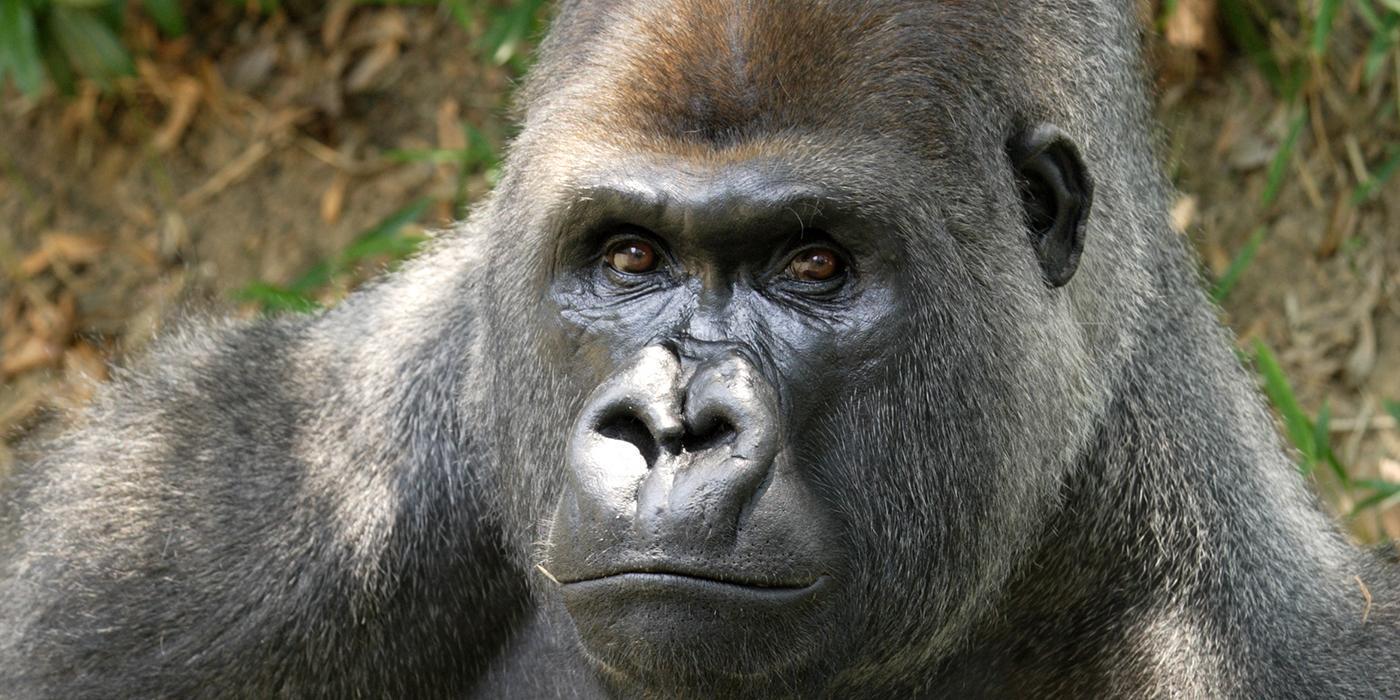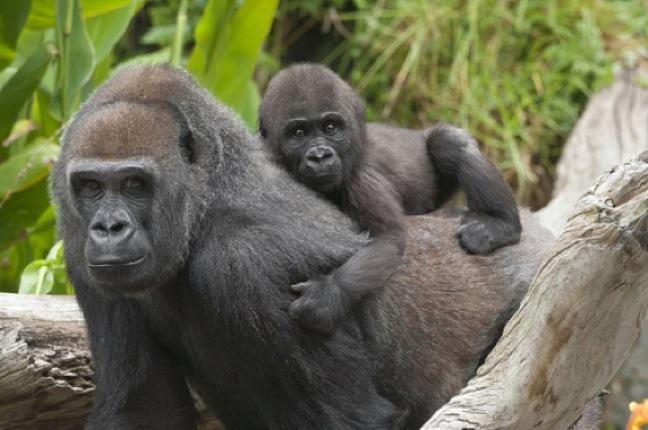The first image is the image on the left, the second image is the image on the right. Evaluate the accuracy of this statement regarding the images: "A baby gorilla is holding onto an adult in an image with only two gorillas.". Is it true? Answer yes or no. Yes. The first image is the image on the left, the second image is the image on the right. Considering the images on both sides, is "The nipples are hanging down on an adult primate in the image on the right." valid? Answer yes or no. No. 